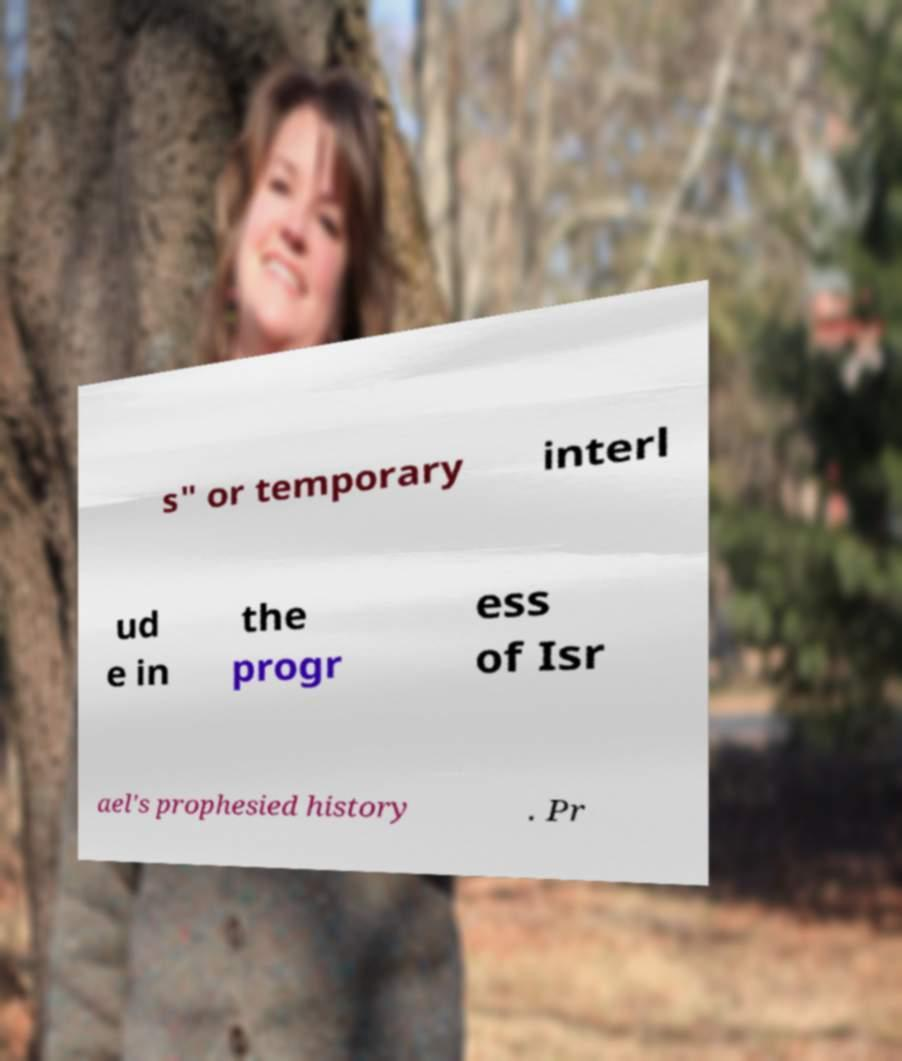Please identify and transcribe the text found in this image. s" or temporary interl ud e in the progr ess of Isr ael's prophesied history . Pr 